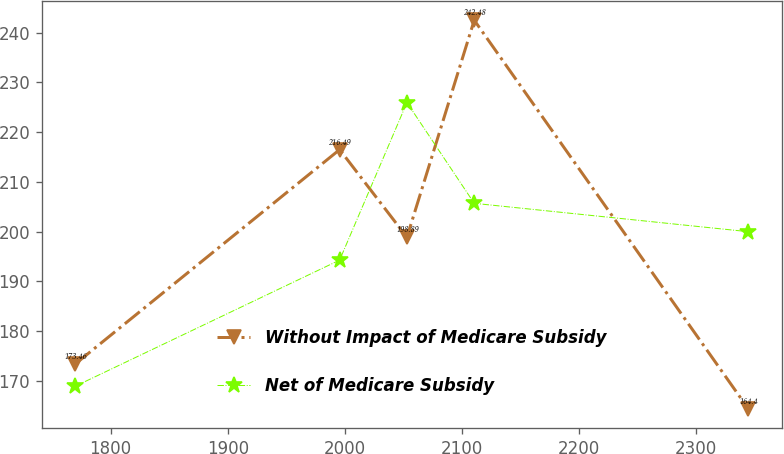<chart> <loc_0><loc_0><loc_500><loc_500><line_chart><ecel><fcel>Without Impact of Medicare Subsidy<fcel>Net of Medicare Subsidy<nl><fcel>1769.9<fcel>173.46<fcel>168.98<nl><fcel>1995.59<fcel>216.49<fcel>194.3<nl><fcel>2053.08<fcel>198.89<fcel>225.94<nl><fcel>2110.57<fcel>242.48<fcel>205.7<nl><fcel>2344.8<fcel>164.4<fcel>200<nl></chart> 